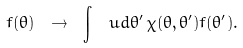<formula> <loc_0><loc_0><loc_500><loc_500>f ( \theta ) \ \to \ \int \, \ u d \theta ^ { \prime } \, \chi ( \theta , \theta ^ { \prime } ) f ( \theta ^ { \prime } ) .</formula> 